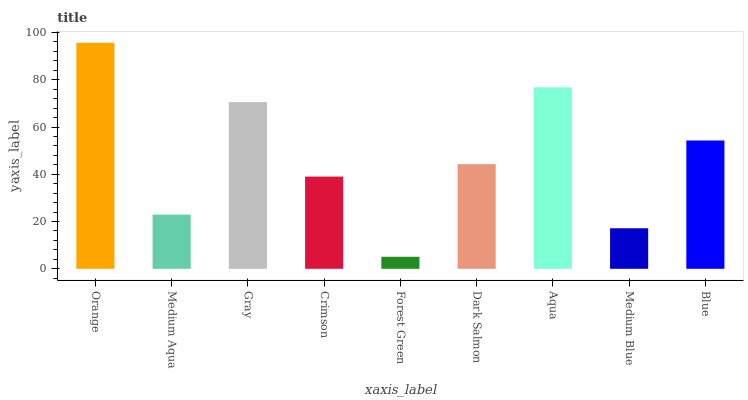Is Forest Green the minimum?
Answer yes or no. Yes. Is Orange the maximum?
Answer yes or no. Yes. Is Medium Aqua the minimum?
Answer yes or no. No. Is Medium Aqua the maximum?
Answer yes or no. No. Is Orange greater than Medium Aqua?
Answer yes or no. Yes. Is Medium Aqua less than Orange?
Answer yes or no. Yes. Is Medium Aqua greater than Orange?
Answer yes or no. No. Is Orange less than Medium Aqua?
Answer yes or no. No. Is Dark Salmon the high median?
Answer yes or no. Yes. Is Dark Salmon the low median?
Answer yes or no. Yes. Is Aqua the high median?
Answer yes or no. No. Is Medium Blue the low median?
Answer yes or no. No. 